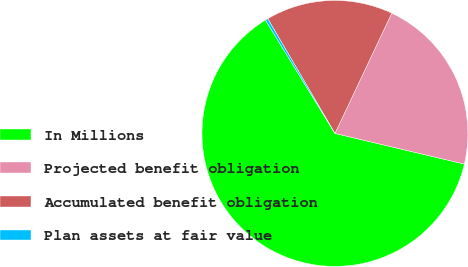<chart> <loc_0><loc_0><loc_500><loc_500><pie_chart><fcel>In Millions<fcel>Projected benefit obligation<fcel>Accumulated benefit obligation<fcel>Plan assets at fair value<nl><fcel>62.54%<fcel>21.68%<fcel>15.46%<fcel>0.32%<nl></chart> 